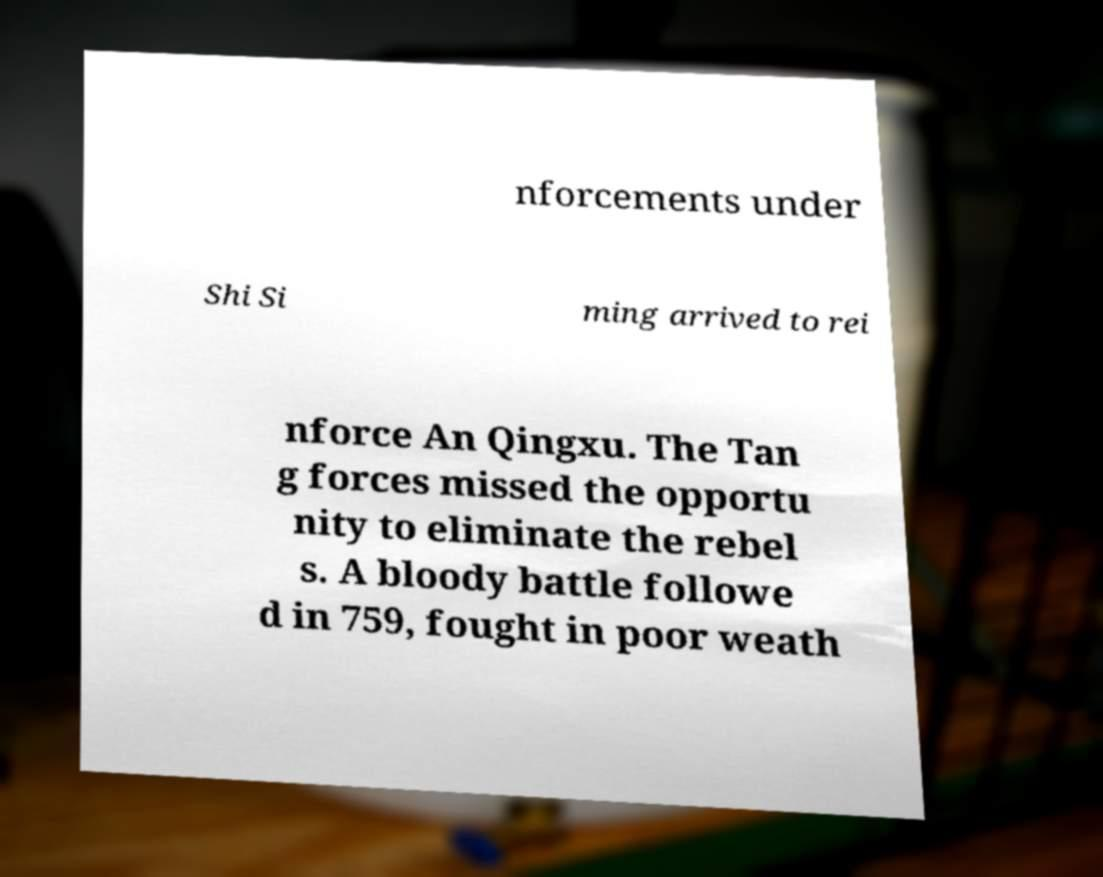Could you extract and type out the text from this image? nforcements under Shi Si ming arrived to rei nforce An Qingxu. The Tan g forces missed the opportu nity to eliminate the rebel s. A bloody battle followe d in 759, fought in poor weath 